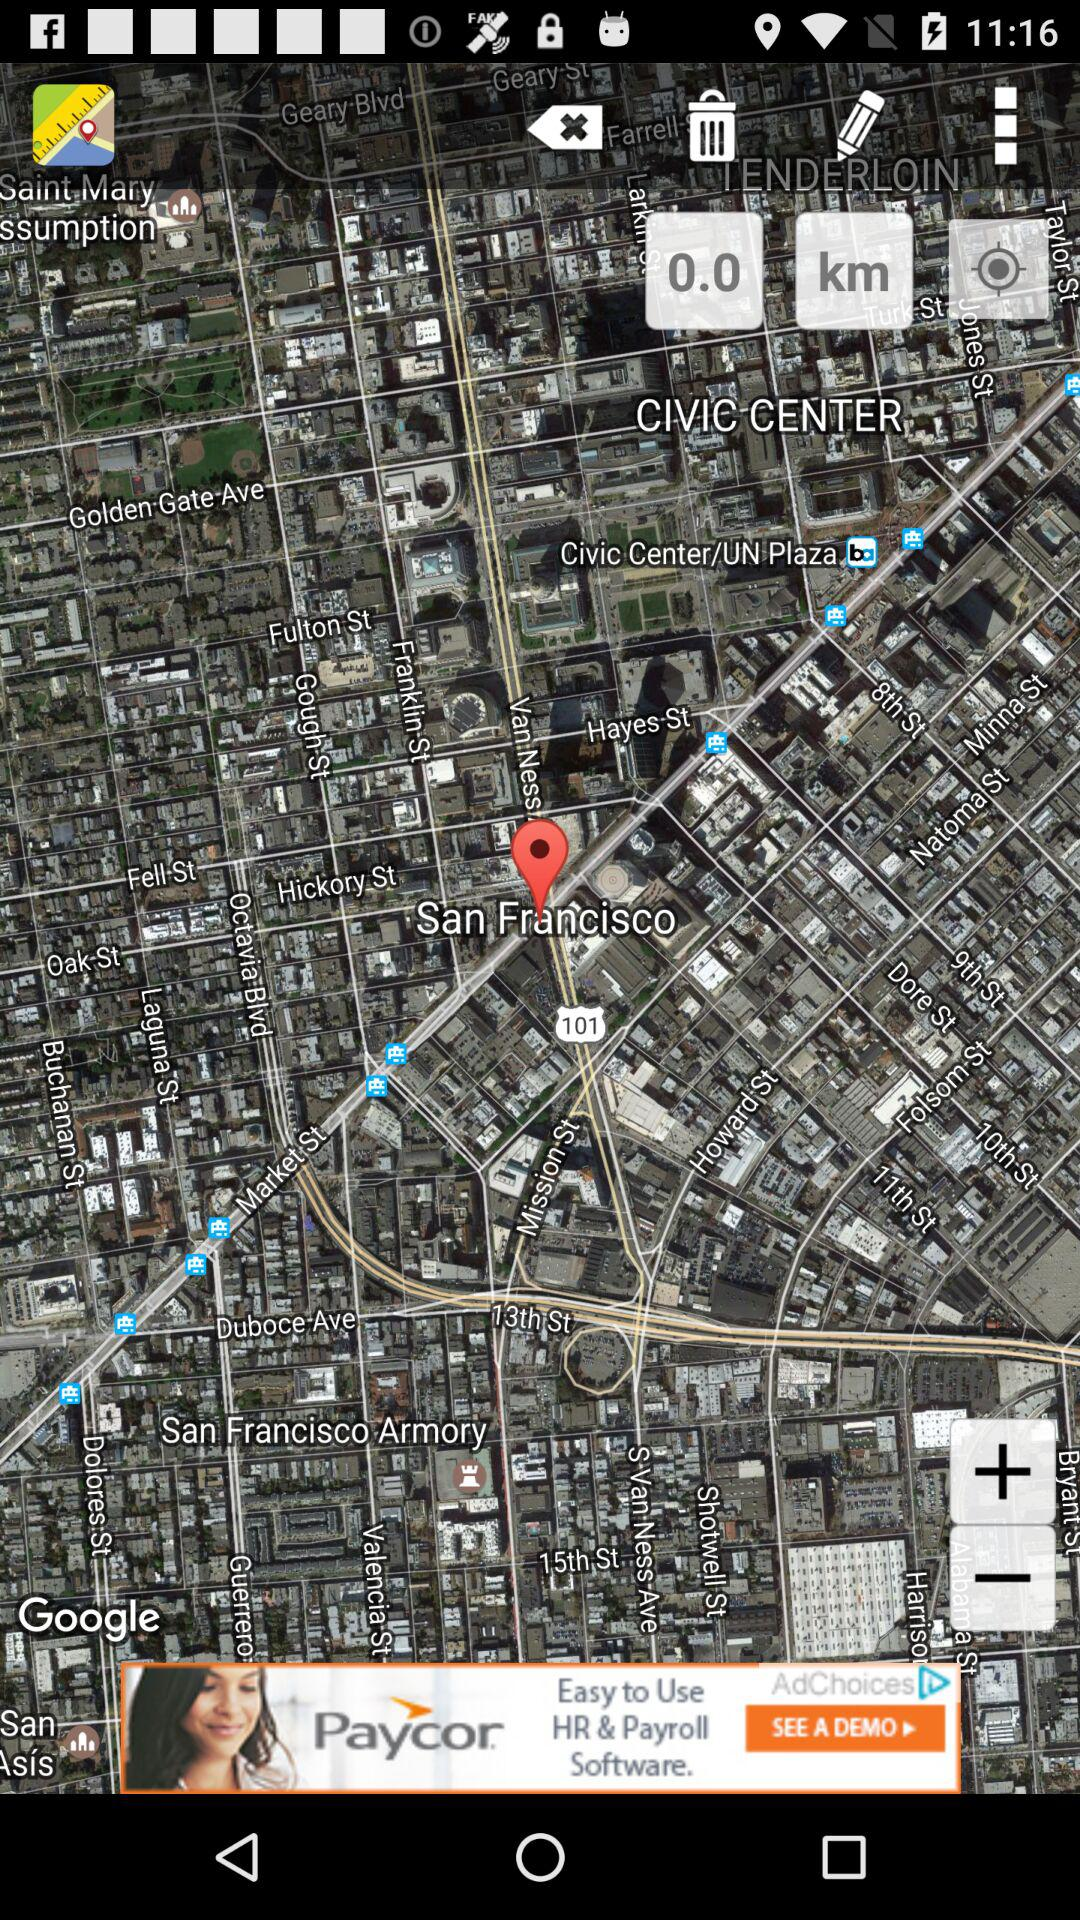What is the street address?
When the provided information is insufficient, respond with <no answer>. <no answer> 